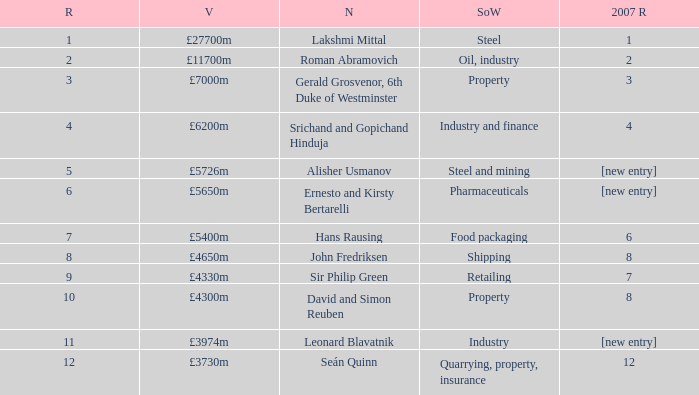What source of wealth has a value of £5726m? Steel and mining. 